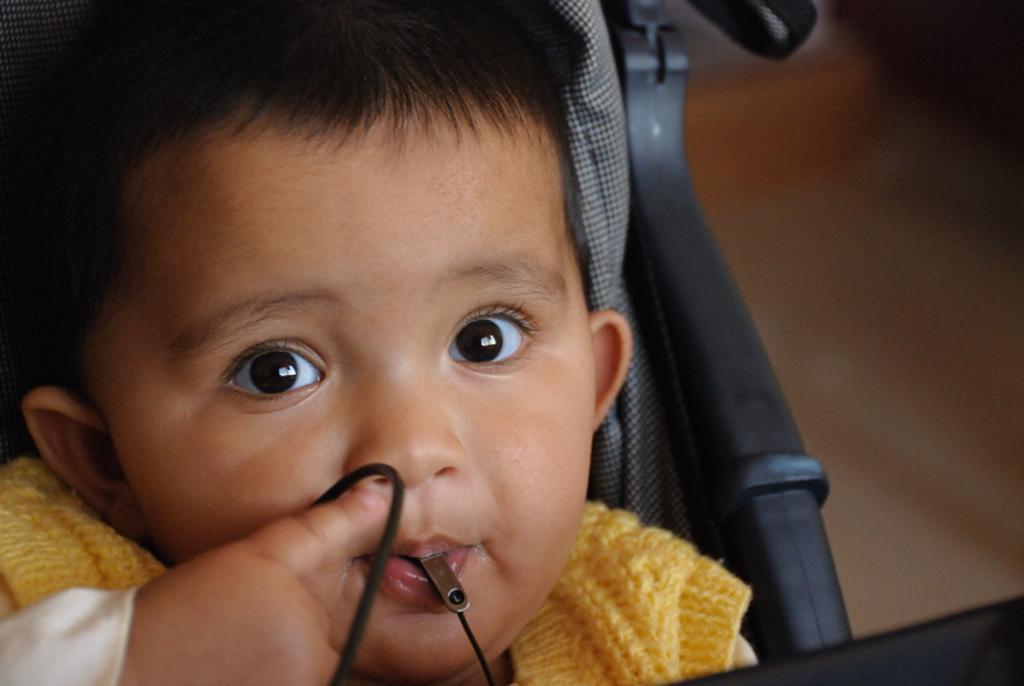In one or two sentences, can you explain what this image depicts? In this picture I can see a boy on an object, and there is blur background. 